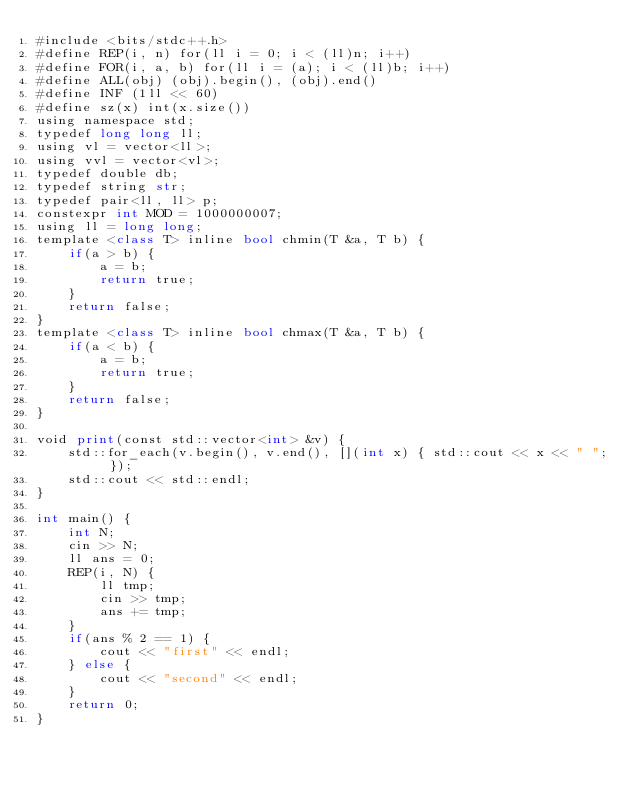<code> <loc_0><loc_0><loc_500><loc_500><_Python_>#include <bits/stdc++.h>
#define REP(i, n) for(ll i = 0; i < (ll)n; i++)
#define FOR(i, a, b) for(ll i = (a); i < (ll)b; i++)
#define ALL(obj) (obj).begin(), (obj).end()
#define INF (1ll << 60)
#define sz(x) int(x.size())
using namespace std;
typedef long long ll;
using vl = vector<ll>;
using vvl = vector<vl>;
typedef double db;
typedef string str;
typedef pair<ll, ll> p;
constexpr int MOD = 1000000007;
using ll = long long;
template <class T> inline bool chmin(T &a, T b) {
    if(a > b) {
        a = b;
        return true;
    }
    return false;
}
template <class T> inline bool chmax(T &a, T b) {
    if(a < b) {
        a = b;
        return true;
    }
    return false;
}

void print(const std::vector<int> &v) {
    std::for_each(v.begin(), v.end(), [](int x) { std::cout << x << " "; });
    std::cout << std::endl;
}

int main() {
    int N;
    cin >> N;
    ll ans = 0;
    REP(i, N) {
        ll tmp;
        cin >> tmp;
        ans += tmp;
    }
    if(ans % 2 == 1) {
        cout << "first" << endl;
    } else {
        cout << "second" << endl;
    }
    return 0;
}</code> 